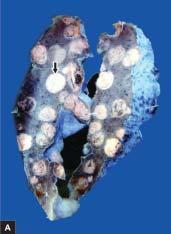how does sectioned surface of the lung show replacement of slaty-grey spongy parenchyma?
Answer the question using a single word or phrase. With multiple 